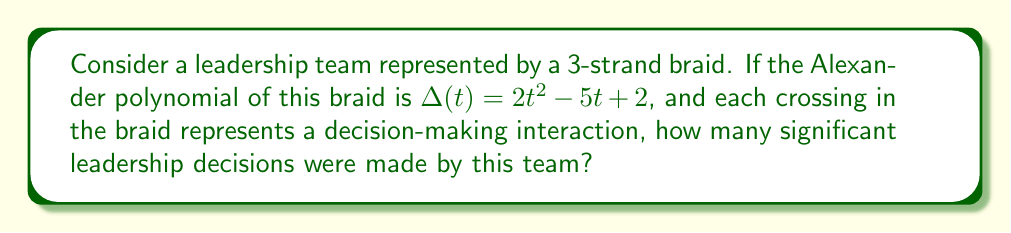Help me with this question. To solve this problem, we'll follow these steps:

1) In knot theory, the Alexander polynomial is a knot invariant that can be used to distinguish between different knots. In our leadership analogy, we're using it to analyze the complexity of leadership interactions.

2) For a 3-strand braid, the degree of the Alexander polynomial is related to the number of crossings in the braid. Specifically, for a 3-strand braid with $n$ crossings, the degree of the Alexander polynomial is at most $n-1$.

3) In this case, the Alexander polynomial is:

   $$\Delta(t) = 2t^2 - 5t + 2$$

4) The degree of this polynomial is 2, as the highest power of $t$ is 2.

5) Using the relationship mentioned in step 2:

   $2 = n - 1$
   $n = 3$

6) Therefore, the braid has 3 crossings.

7) In our leadership analogy, each crossing represents a significant decision-making interaction. Thus, the team made 3 significant leadership decisions.
Answer: 3 